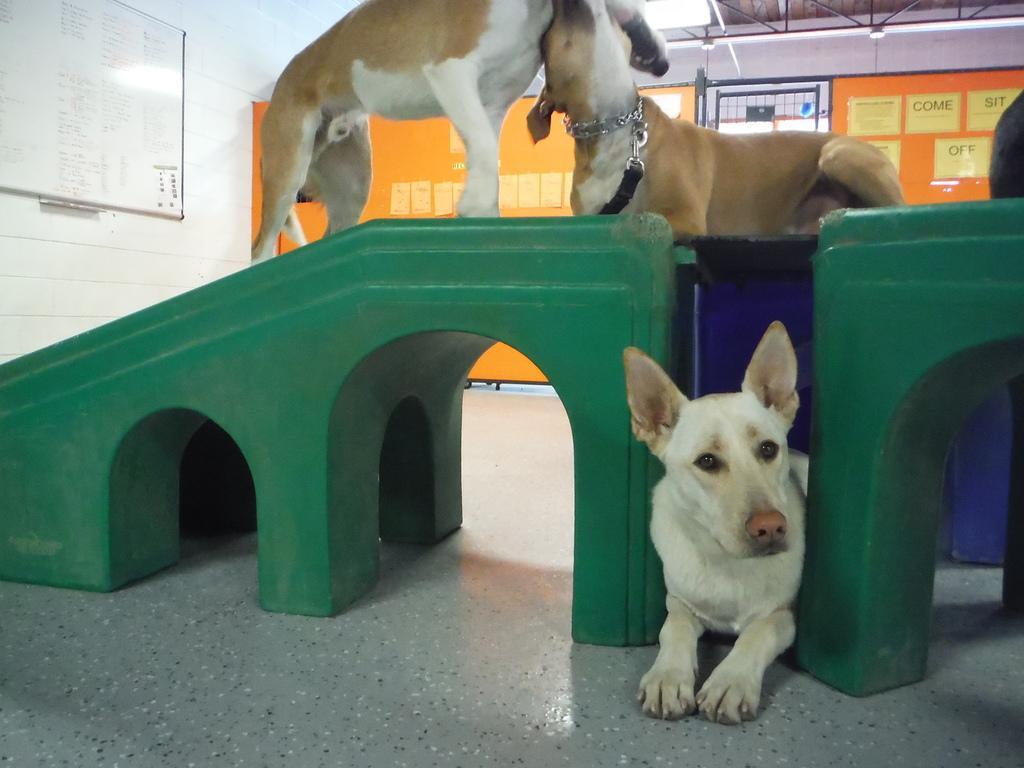Can you describe this image briefly? In the background we can see the posters. In this picture we can see a white board, lights. In this picture we can see dogs and few objects. At the bottom portion of the picture we can see the floor. 